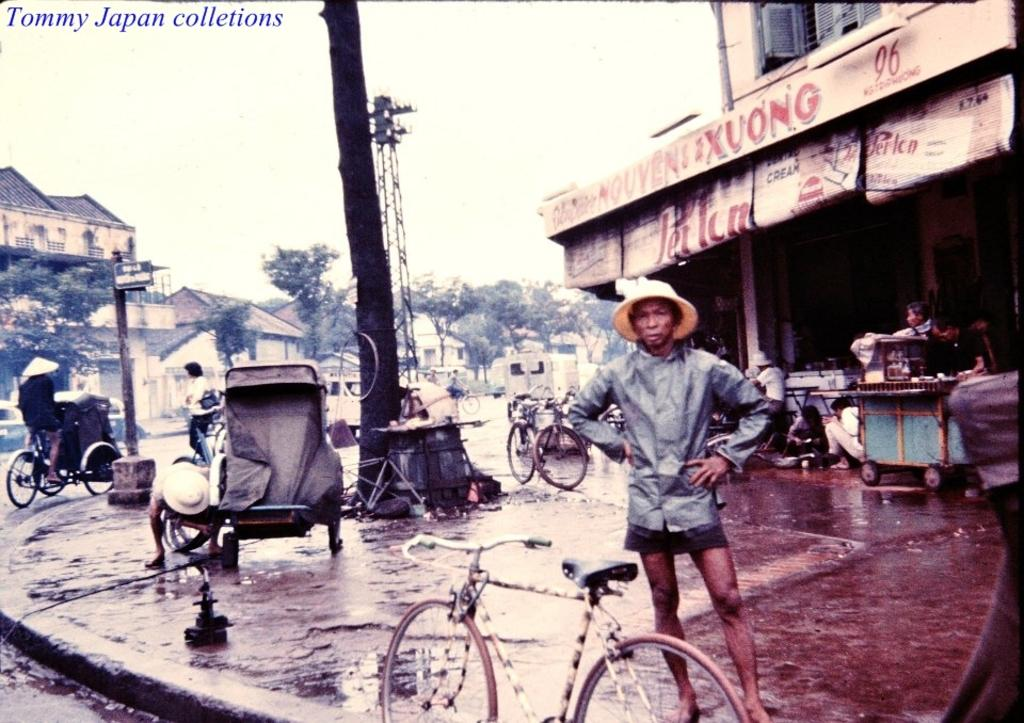What is the main subject of the image? There is a man standing in the image. What is the man wearing on his head? The man is wearing a hat. What can be seen besides the man in the image? There is a cycle, a shop, trees, sky, and houses in the image. What type of church can be seen in the image? There is no church present in the image. How many thumbs does the man have in the image? The image does not show the man's thumbs, so it cannot be determined from the image. 